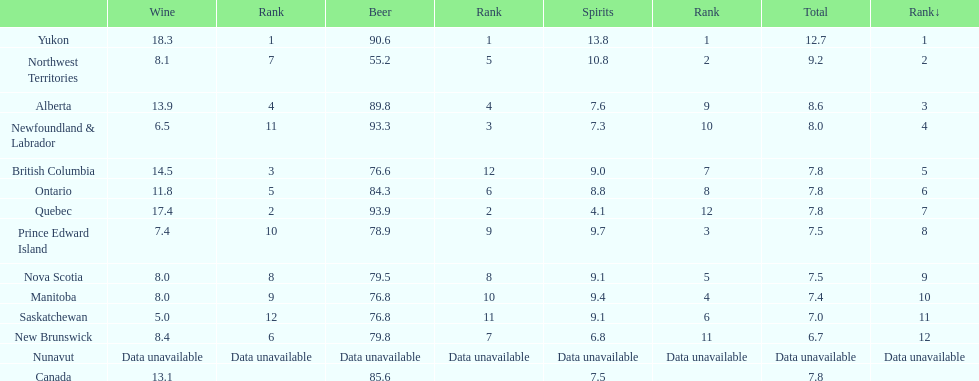In which canadian territory was the beer consumption 93.9? Quebec. What was the consumption of spirits in that territory? 4.1. 